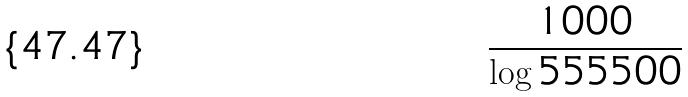<formula> <loc_0><loc_0><loc_500><loc_500>\frac { 1 0 0 0 } { \log 5 5 5 5 0 0 }</formula> 